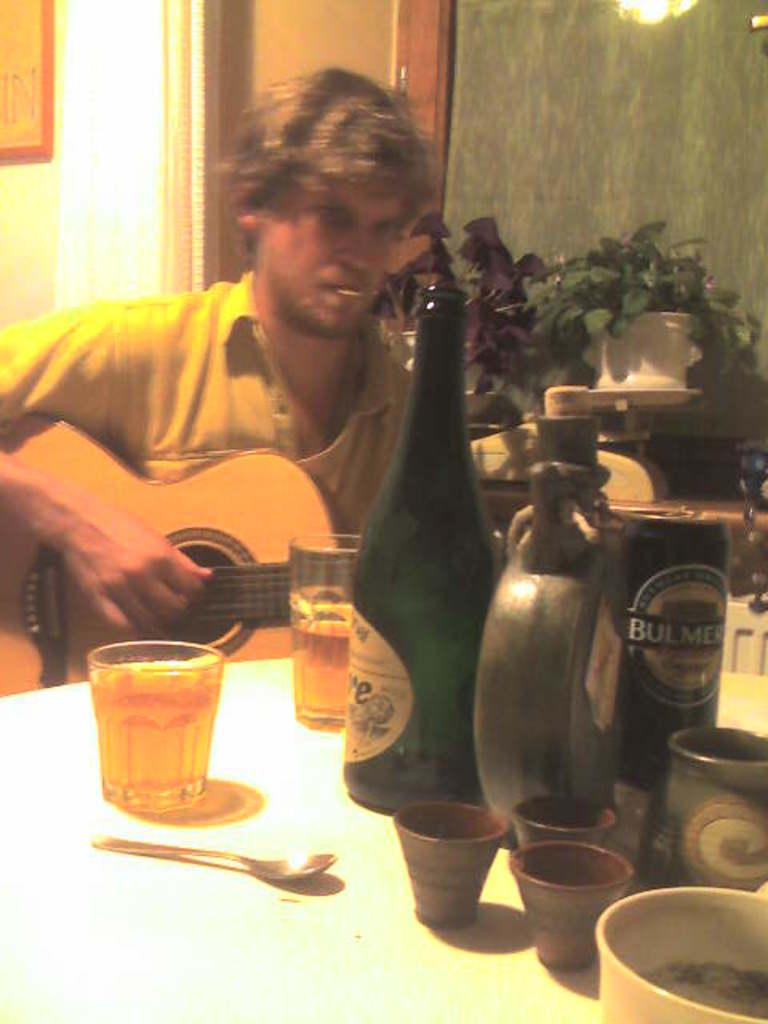<image>
Provide a brief description of the given image. A man with yellow shirt picking a guitar with bulmer on a can. 